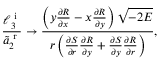Convert formula to latex. <formula><loc_0><loc_0><loc_500><loc_500>\frac { \ell _ { 3 } ^ { i } } { \tilde { a } _ { 2 } ^ { r } } \rightarrow \frac { \left ( y \frac { \partial R } { \partial x } - x \frac { \partial R } { \partial y } \right ) \sqrt { - 2 E } } { r \left ( \frac { \partial S } { \partial r } \frac { \partial R } { \partial y } + \frac { \partial S } { \partial y } \frac { \partial R } { \partial r } \right ) } ,</formula> 